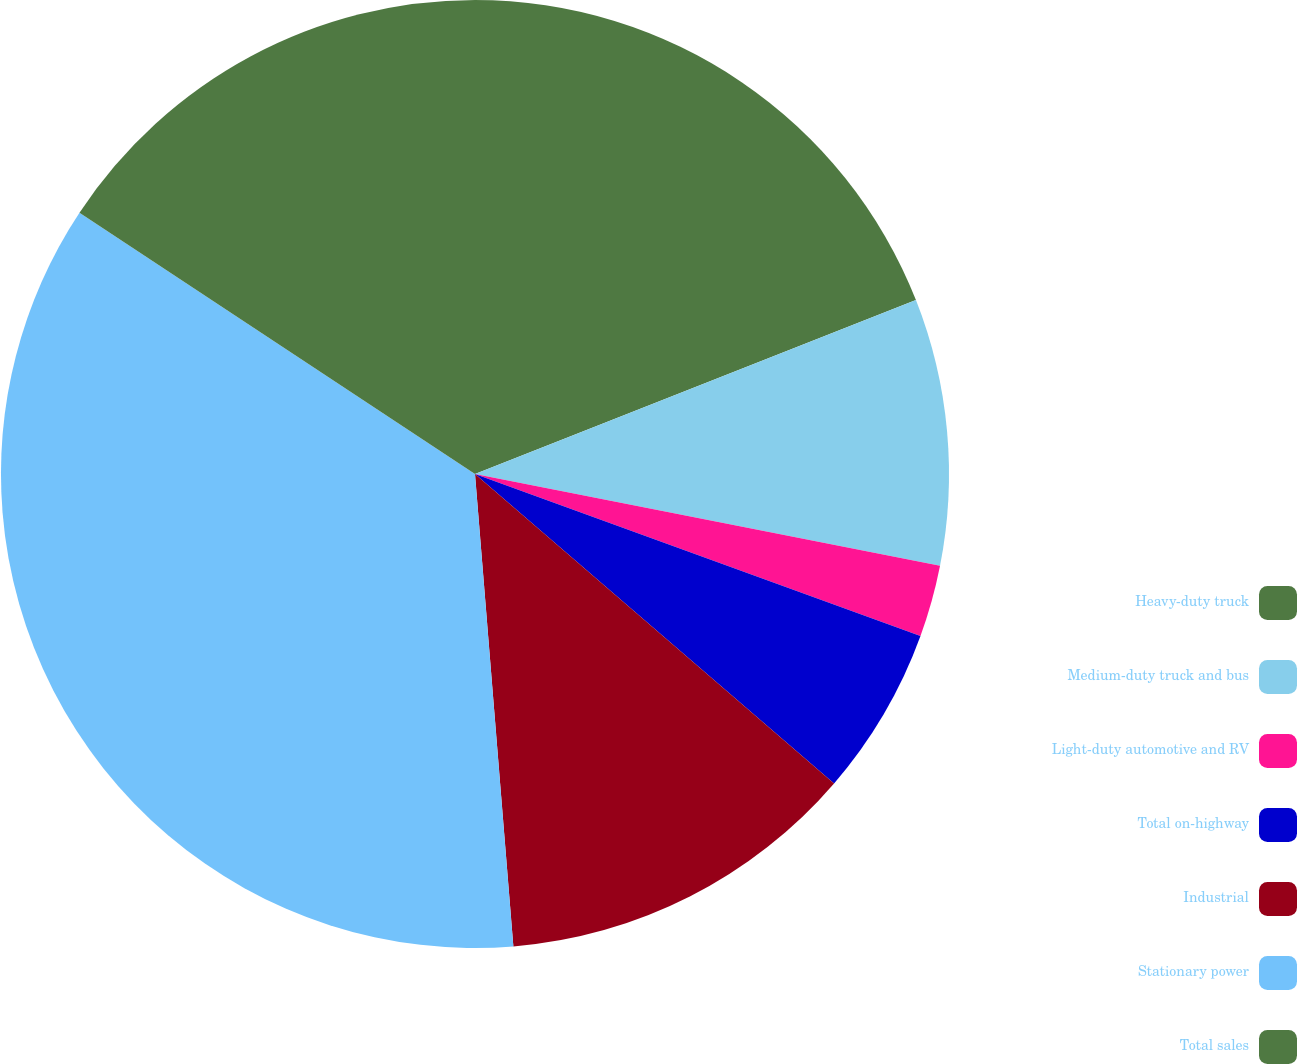Convert chart to OTSL. <chart><loc_0><loc_0><loc_500><loc_500><pie_chart><fcel>Heavy-duty truck<fcel>Medium-duty truck and bus<fcel>Light-duty automotive and RV<fcel>Total on-highway<fcel>Industrial<fcel>Stationary power<fcel>Total sales<nl><fcel>19.02%<fcel>9.08%<fcel>2.45%<fcel>5.77%<fcel>12.39%<fcel>35.58%<fcel>15.71%<nl></chart> 